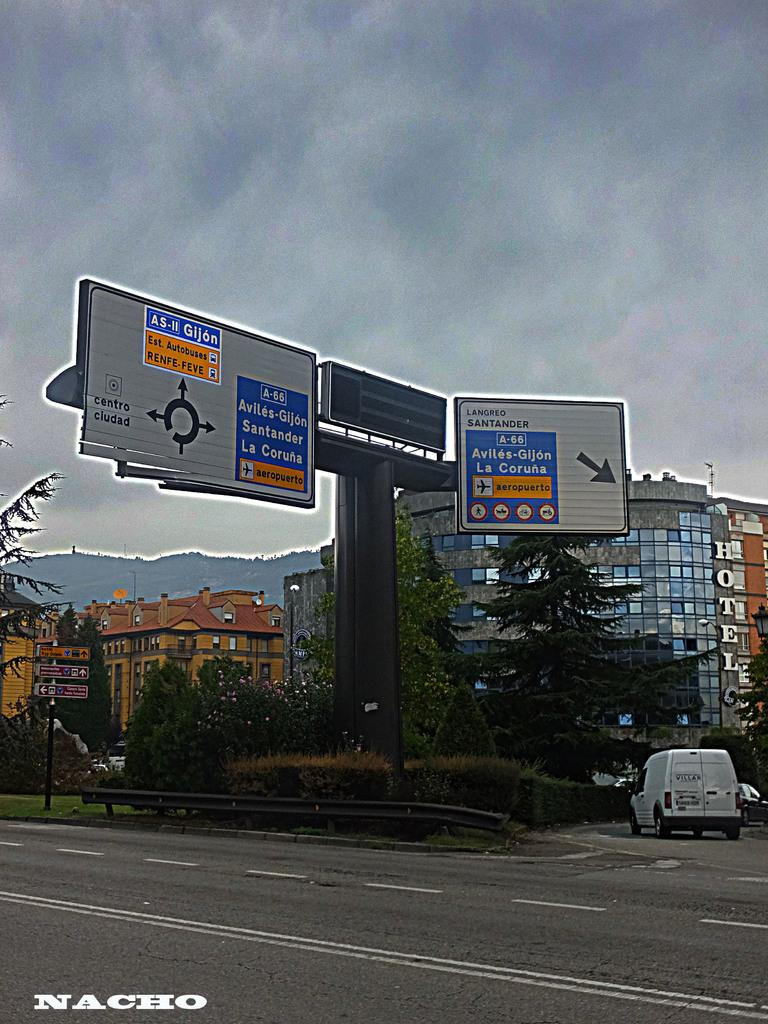<image>
Offer a succinct explanation of the picture presented. a sign has the name Gijon on it 